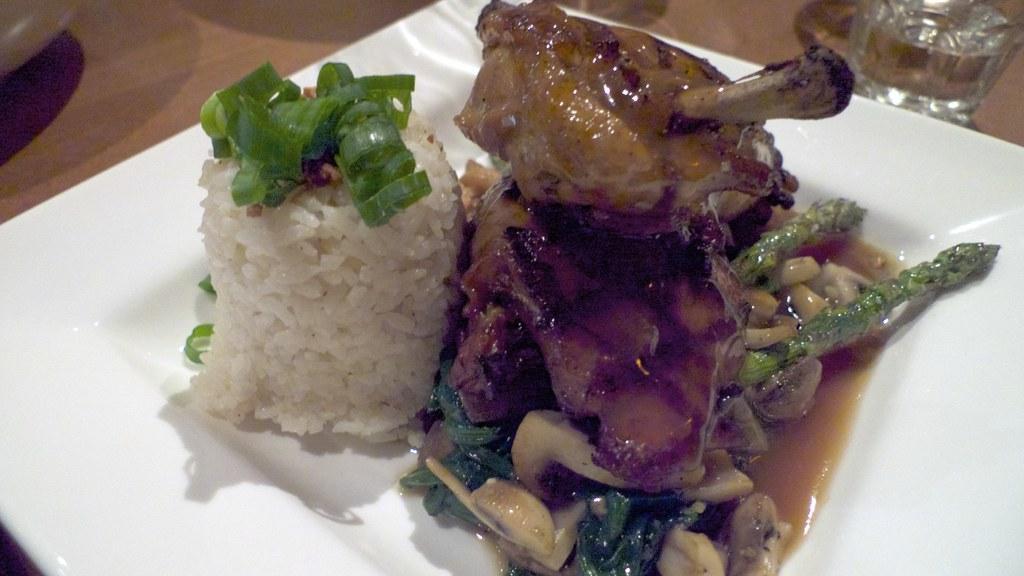Could you give a brief overview of what you see in this image? In this image I can see the food in the white plate. I can see the food is colorful. To the side I can see the glass. These are on the brown color surface. 